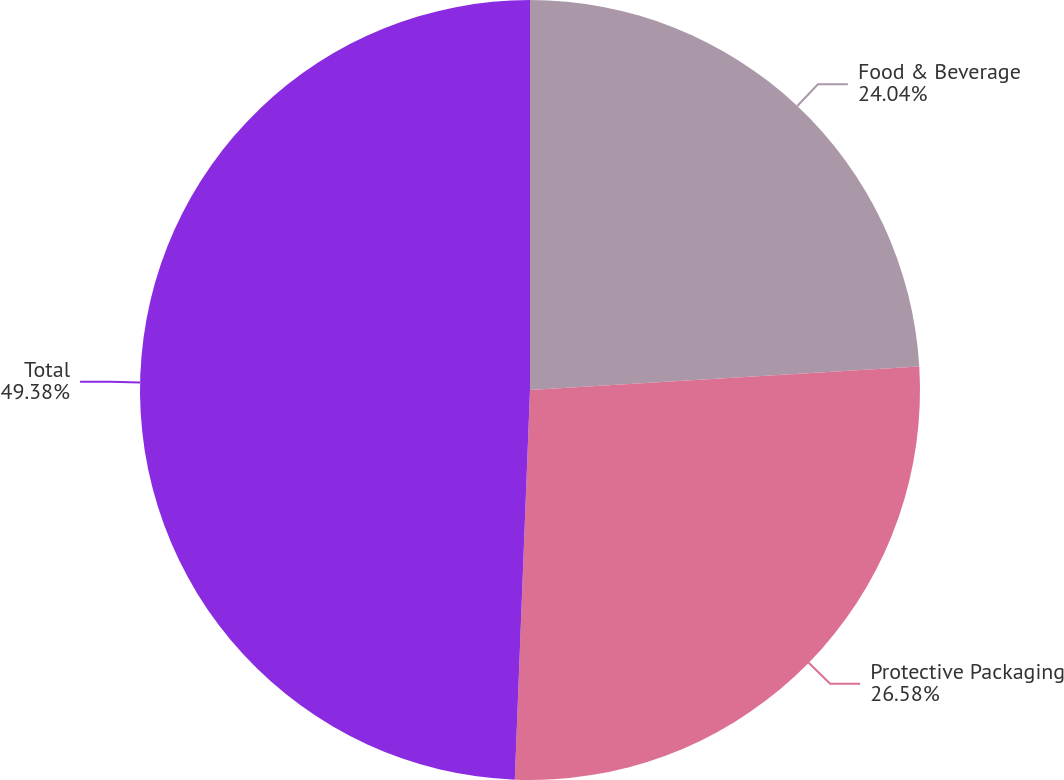Convert chart to OTSL. <chart><loc_0><loc_0><loc_500><loc_500><pie_chart><fcel>Food & Beverage<fcel>Protective Packaging<fcel>Total<nl><fcel>24.04%<fcel>26.58%<fcel>49.38%<nl></chart> 